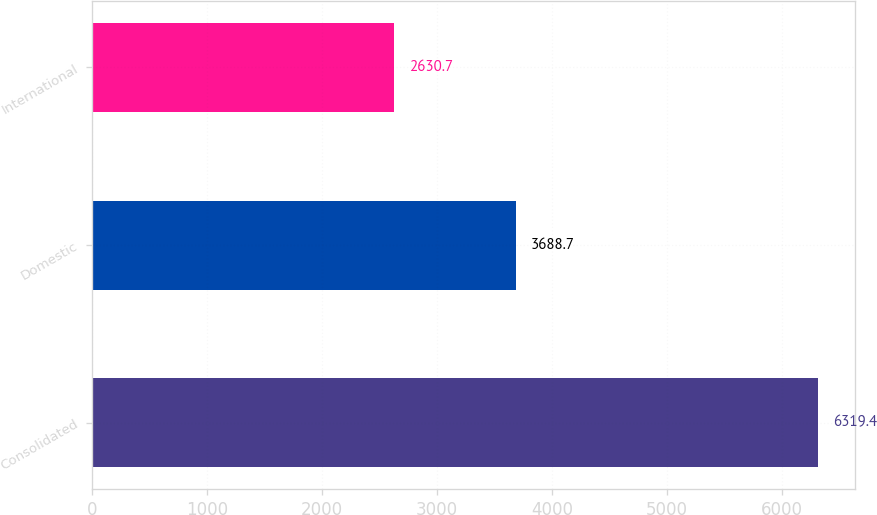Convert chart. <chart><loc_0><loc_0><loc_500><loc_500><bar_chart><fcel>Consolidated<fcel>Domestic<fcel>International<nl><fcel>6319.4<fcel>3688.7<fcel>2630.7<nl></chart> 